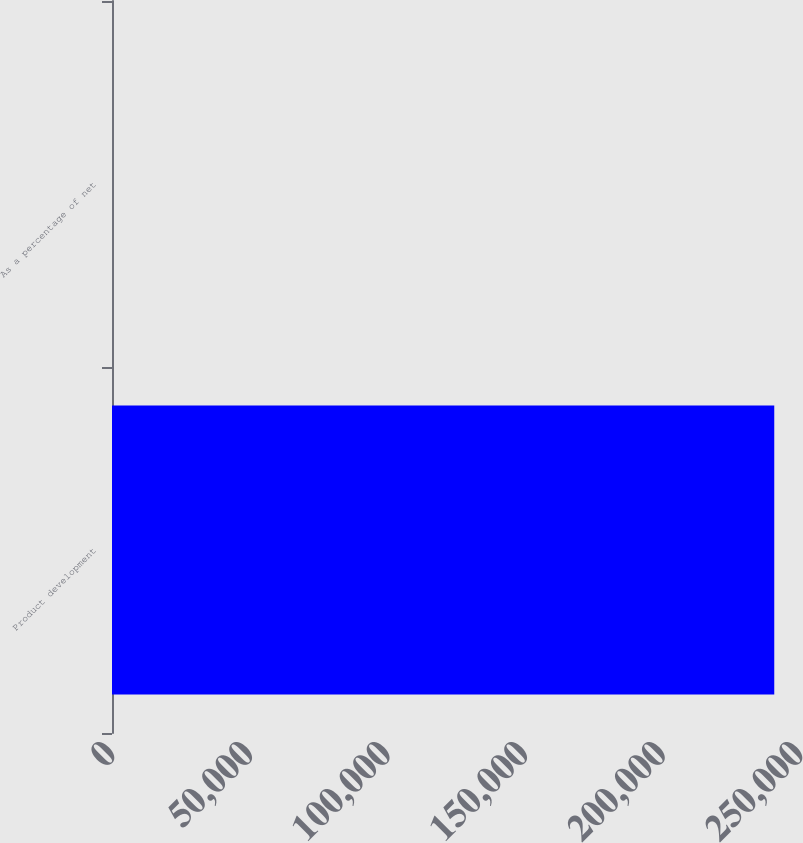Convert chart to OTSL. <chart><loc_0><loc_0><loc_500><loc_500><bar_chart><fcel>Product development<fcel>As a percentage of net<nl><fcel>240647<fcel>7.4<nl></chart> 